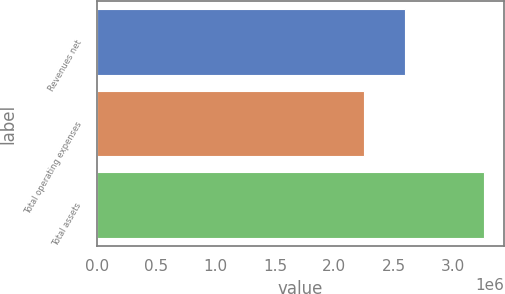Convert chart. <chart><loc_0><loc_0><loc_500><loc_500><bar_chart><fcel>Revenues net<fcel>Total operating expenses<fcel>Total assets<nl><fcel>2.59333e+06<fcel>2.24666e+06<fcel>3.26467e+06<nl></chart> 